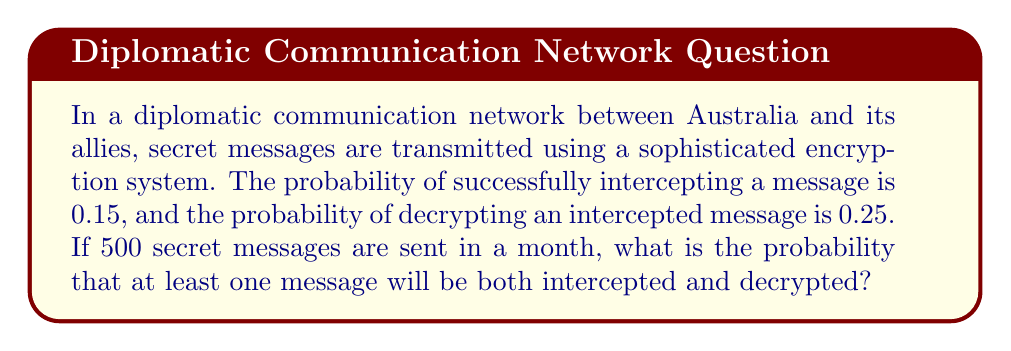Could you help me with this problem? Let's approach this step-by-step:

1) First, we need to calculate the probability of successfully intercepting and decrypting a single message:

   $P(\text{intercept and decrypt}) = P(\text{intercept}) \times P(\text{decrypt | intercept})$
   $= 0.15 \times 0.25 = 0.0375$

2) Now, we want to find the probability of at least one success in 500 trials. It's easier to calculate the probability of no successes and then subtract from 1:

   $P(\text{at least one success}) = 1 - P(\text{no successes})$

3) The probability of no successes in 500 trials is:

   $P(\text{no successes}) = (1 - 0.0375)^{500}$

4) Let's calculate this:

   $P(\text{no successes}) = (0.9625)^{500} \approx 1.079 \times 10^{-9}$

5) Therefore, the probability of at least one success is:

   $P(\text{at least one success}) = 1 - (1.079 \times 10^{-9}) \approx 0.999999999$

6) This can be rounded to 1 for all practical purposes.
Answer: $\approx 1$ or $0.999999999$ 